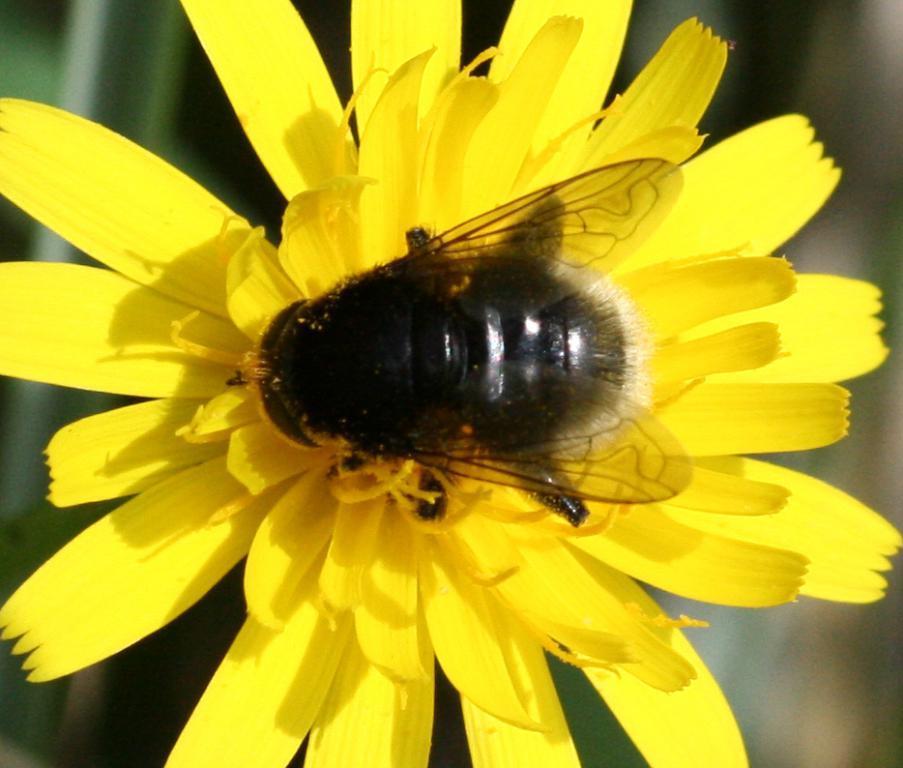Could you give a brief overview of what you see in this image? In this picture we can see an insect on the flower. 